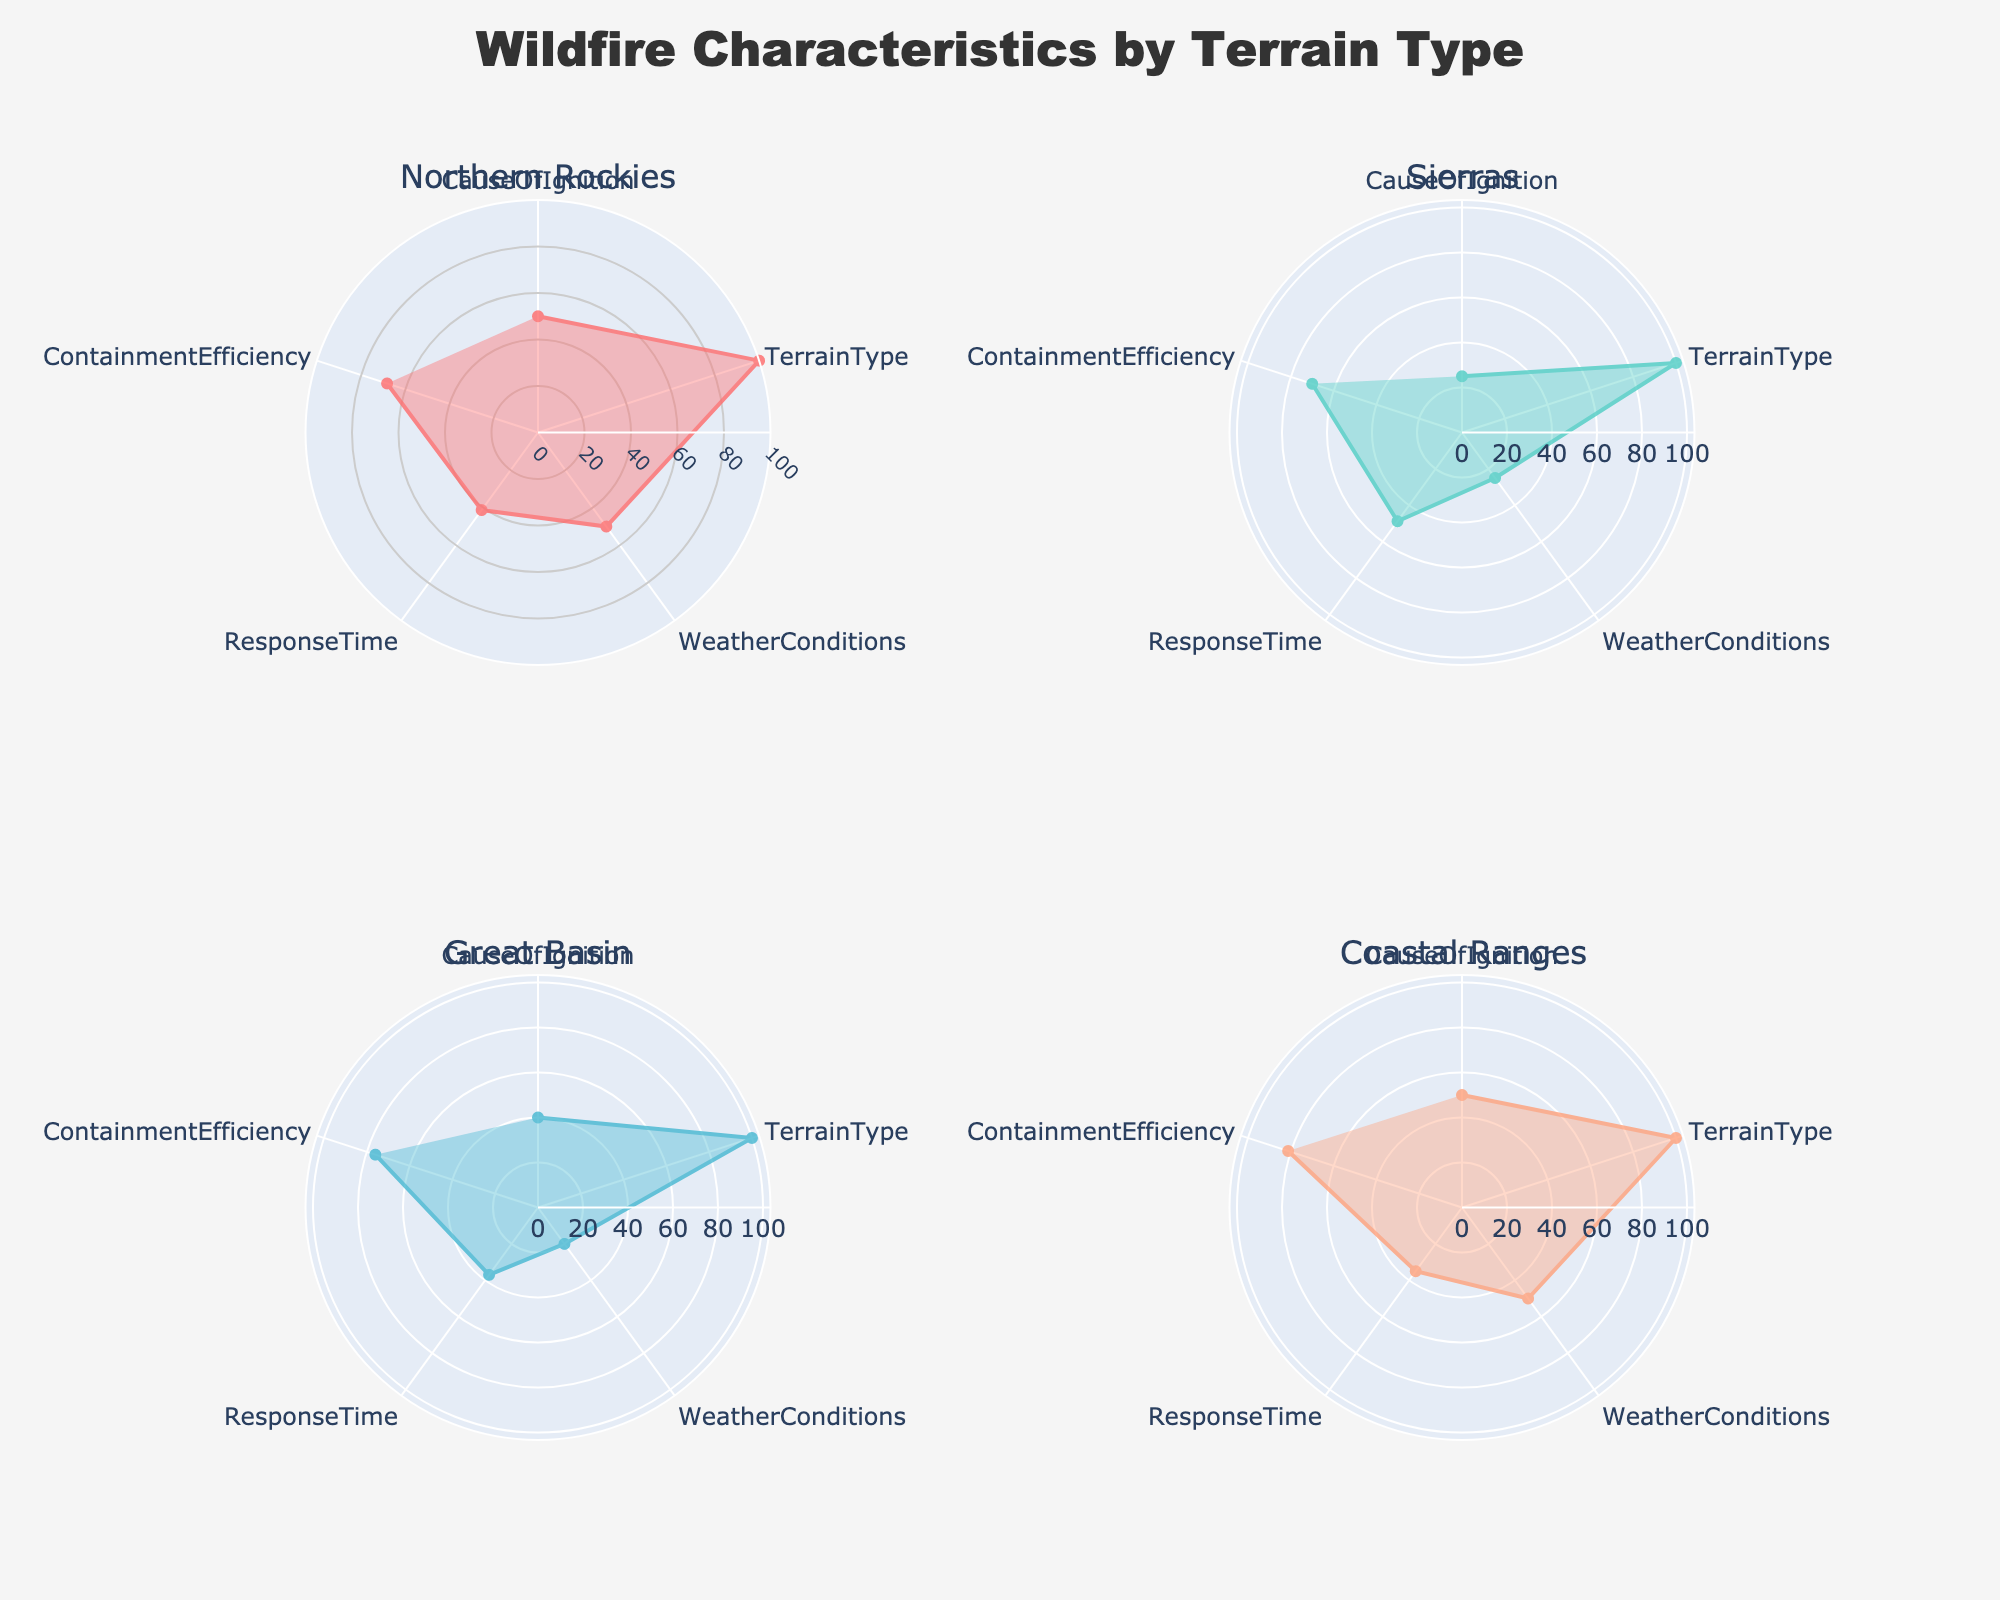What's the title of the figure? The title is displayed at the top-center of the figure and is often the most prominent text. In this case, it should summarize what the figure is about.
Answer: Wildfire Characteristics by Terrain Type What terrain type has the highest average containment efficiency? To determine this, look at the radial value for "Containment Efficiency" for each terrain type and identify the highest one.
Answer: Coastal Ranges Which terrain appears to have the longest average response time? The radar chart shows a value for "Response Time" for each terrain type. Compare these values to find the longest one.
Answer: Northern Rockies Which weather condition is most prevalent in the Sierras? Refer to the "Weather Conditions" section of the radar chart for the Sierras subplot to see which condition has the highest value.
Answer: Hot and Dry How does the prevalence of human-caused ignitions in the Northern Rockies compare to the Sierras? Look at the "Cause of Ignition" section for both the Northern Rockies and the Sierras and compare the percentages for "Human."
Answer: Higher in Northern Rockies What is the average response time for terrain types that have a 100% prevalence of "Hot and Dry" weather conditions? Identify the terrains with 100% "Hot and Dry" and then calculate the average response time for those terrain types. The Sierras and Cascades have 100% "Hot and Dry". Sierras: 30, Cascades: 42.5. (30 + 42.5) / 2 = 36.25
Answer: 36.25 What is the commonality found in "Weather Conditions" among all terrain types? Check the "Weather Conditions" segment for all subplots to see if any condition appears consistently.
Answer: Hot and Dry Which color is used to represent the Coastal Ranges terrain? Observing the visual elements of the radar charts, each terrain type is represented with a distinct color. Identify the color for Coastal Ranges.
Answer: Coral What is the minimum average containment efficiency among the terrain types? Look at the "Containment Efficiency" section for each terrain type's radar charts and identify the minimum value.
Answer: 58 (Northern Rockies) How does the containment efficiency in the Great Basin compare to the Coastal Ranges? Compare the "Containment Efficiency" radial values in the Great Basin and Coastal Ranges subplots to determine which is higher.
Answer: Higher in Coastal Ranges 